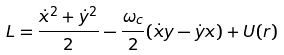<formula> <loc_0><loc_0><loc_500><loc_500>L = \frac { \dot { x } ^ { 2 } + \dot { y } ^ { 2 } } { 2 } - \frac { \omega _ { c } } { 2 } ( \dot { x } y - \dot { y } x ) + U ( r )</formula> 